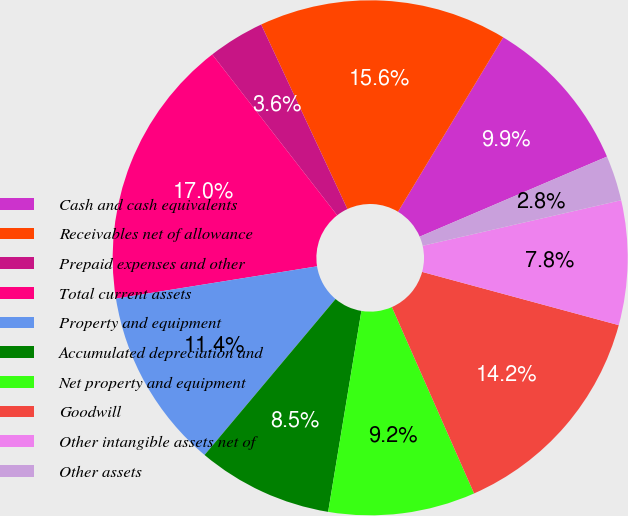Convert chart to OTSL. <chart><loc_0><loc_0><loc_500><loc_500><pie_chart><fcel>Cash and cash equivalents<fcel>Receivables net of allowance<fcel>Prepaid expenses and other<fcel>Total current assets<fcel>Property and equipment<fcel>Accumulated depreciation and<fcel>Net property and equipment<fcel>Goodwill<fcel>Other intangible assets net of<fcel>Other assets<nl><fcel>9.93%<fcel>15.6%<fcel>3.55%<fcel>17.02%<fcel>11.35%<fcel>8.51%<fcel>9.22%<fcel>14.18%<fcel>7.8%<fcel>2.84%<nl></chart> 